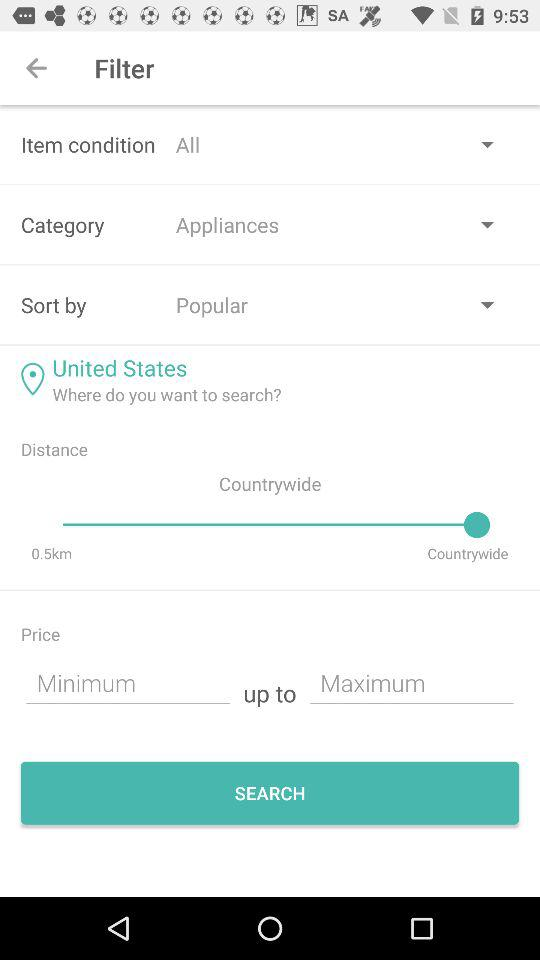What is the price range given? The given price range is "Minimum up to Maximum". 